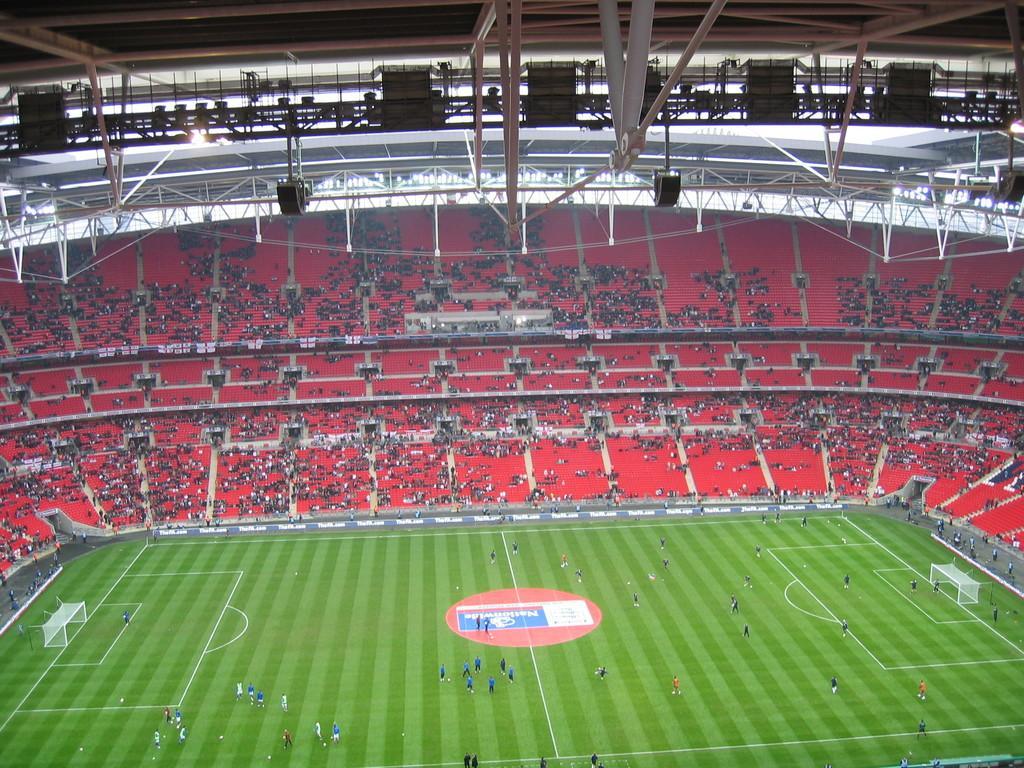Please provide a concise description of this image. This picture looks like a football stadium and I can see few players on the ground and I can see audience and I can see couple of goal posts. 